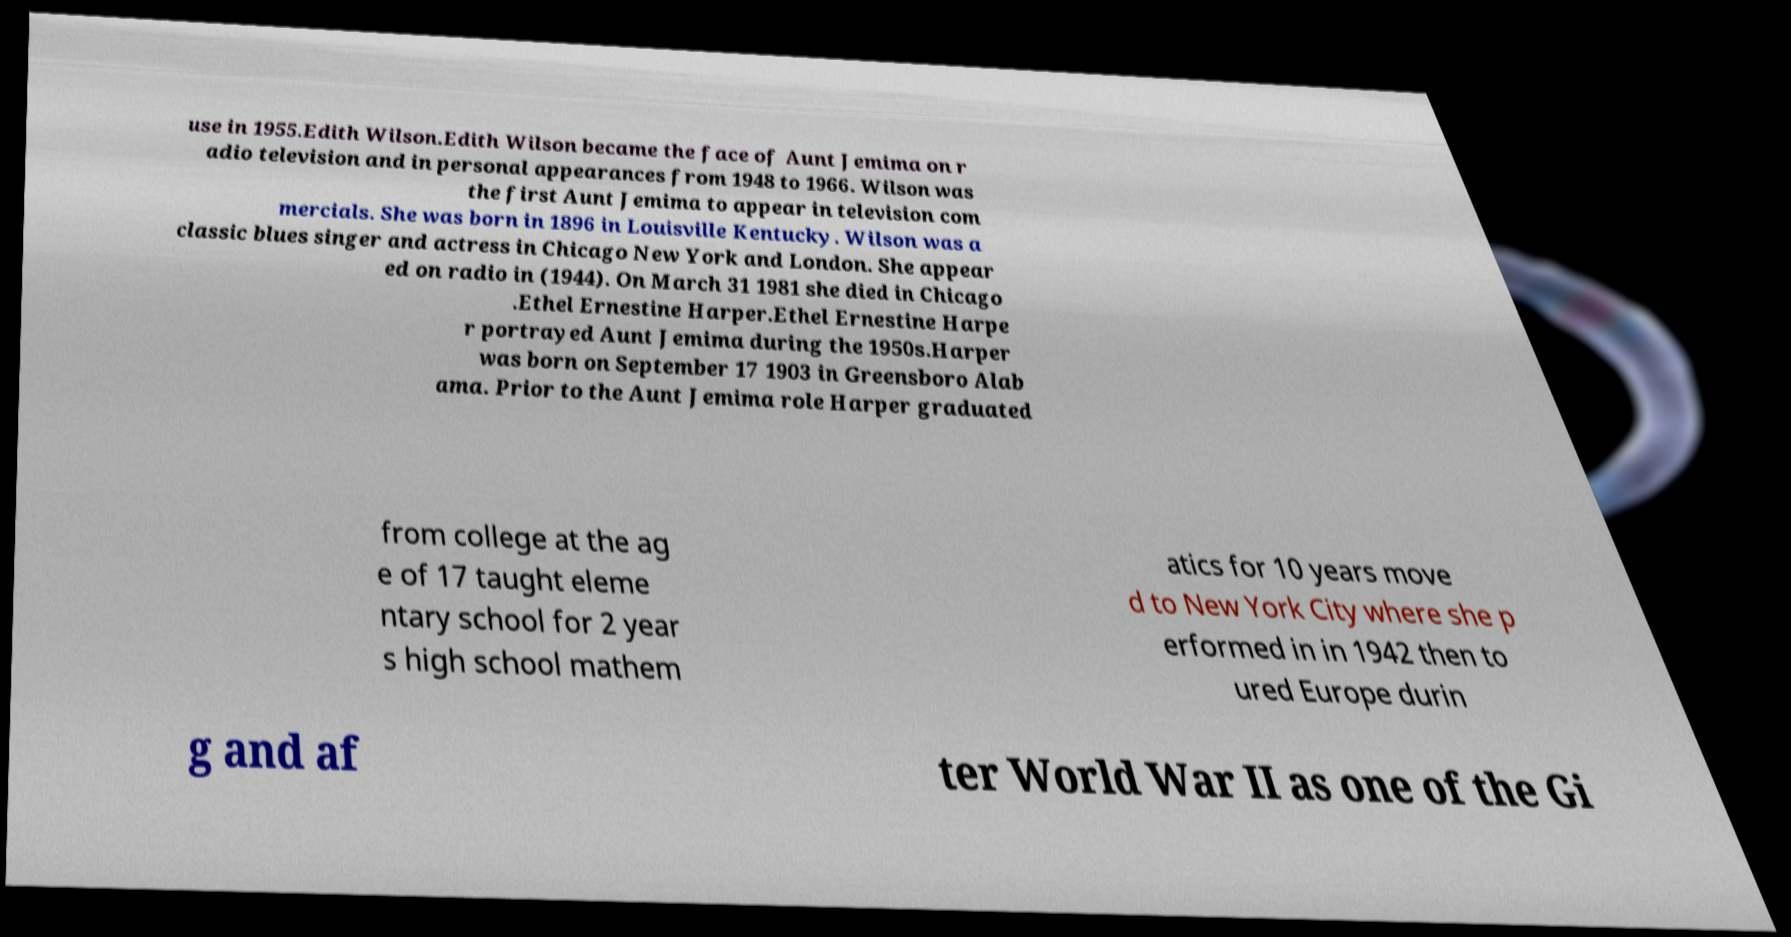Please read and relay the text visible in this image. What does it say? use in 1955.Edith Wilson.Edith Wilson became the face of Aunt Jemima on r adio television and in personal appearances from 1948 to 1966. Wilson was the first Aunt Jemima to appear in television com mercials. She was born in 1896 in Louisville Kentucky. Wilson was a classic blues singer and actress in Chicago New York and London. She appear ed on radio in (1944). On March 31 1981 she died in Chicago .Ethel Ernestine Harper.Ethel Ernestine Harpe r portrayed Aunt Jemima during the 1950s.Harper was born on September 17 1903 in Greensboro Alab ama. Prior to the Aunt Jemima role Harper graduated from college at the ag e of 17 taught eleme ntary school for 2 year s high school mathem atics for 10 years move d to New York City where she p erformed in in 1942 then to ured Europe durin g and af ter World War II as one of the Gi 